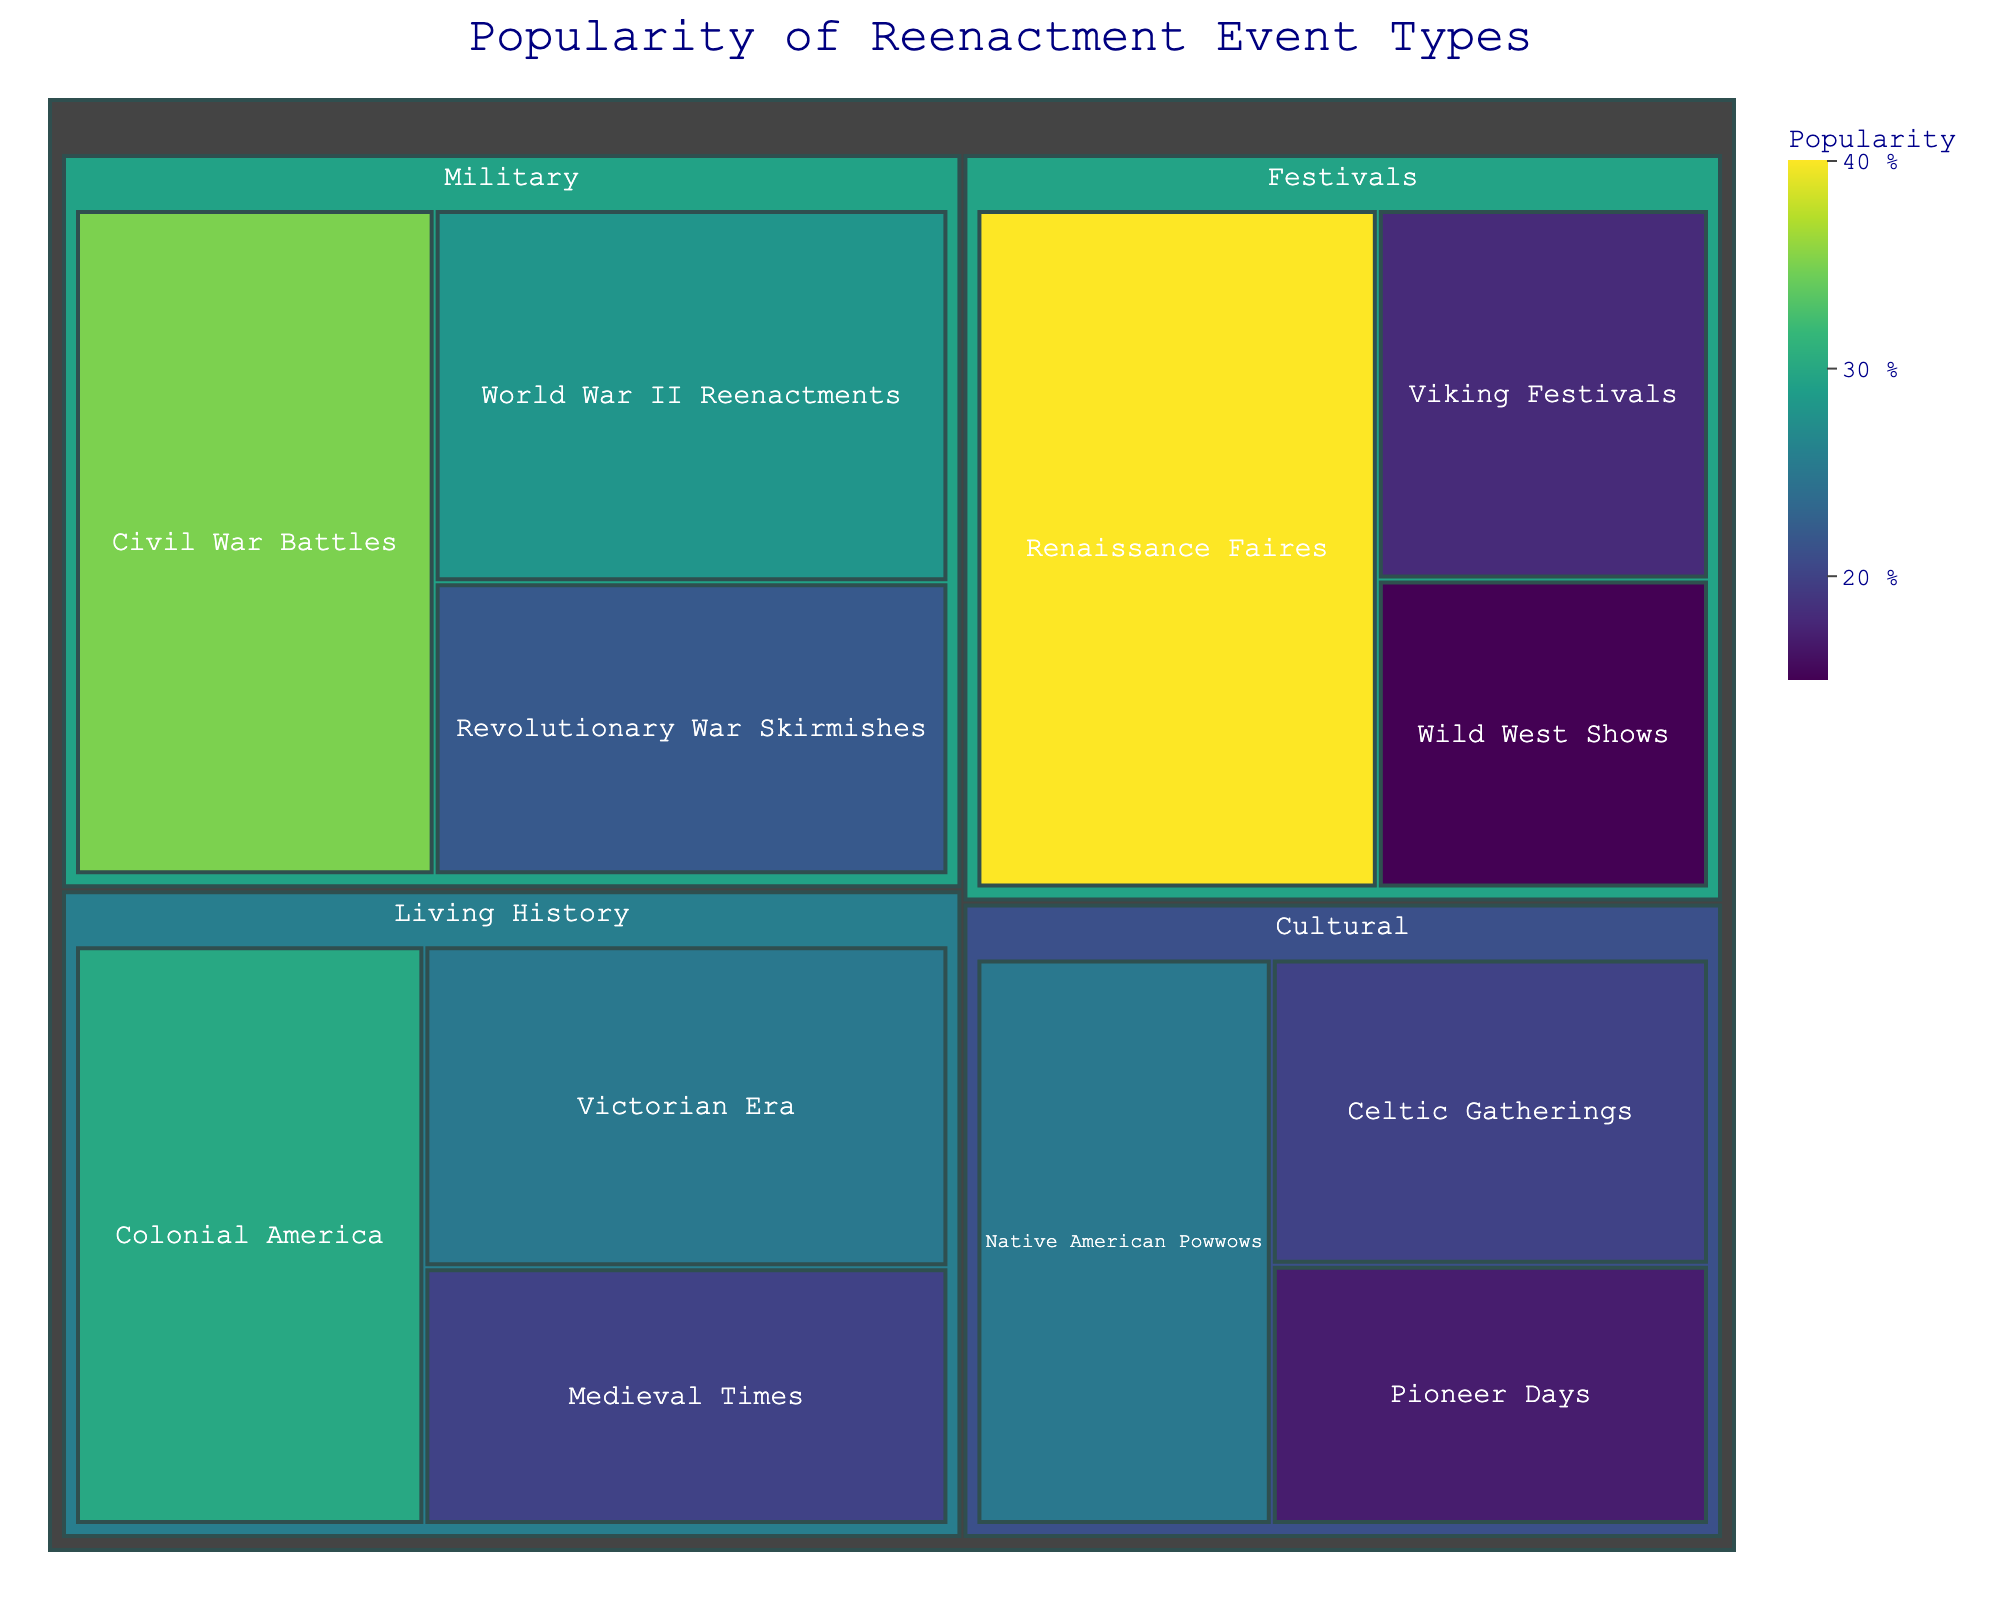Which event type has the highest popularity? Look at the values in the treemap and find the highest, which is "Renaissance Faires" under the Festivals category with a value of 40%.
Answer: Renaissance Faires Which category has the lowest total popularity? Sum up the popularity values for each category: Military (35+28+22=85), Living History (30+25+20=75), Festivals (40+18+15=73), Cultural (25+20+17=62). The Cultural category has the lowest total popularity.
Answer: Cultural What is the popularity difference between Civil War Battles and Viking Festivals? Subtract the popularity value of Viking Festivals (18%) from Civil War Battles (35%). The difference is 35% - 18% = 17%.
Answer: 17% Which event type is more popular: World War II Reenactments or Colonial America? Compare the popularity values of World War II Reenactments (28%) and Colonial America (30%). Colonial America is more popular.
Answer: Colonial America How many event types have a popularity greater than 25%? Identify and count the event types with popularity values greater than 25%: Civil War Battles (35%), Renaissance Faires (40%), Colonial America (30%), World War II Reenactments (28%). There are 4 event types with popularity greater than 25%.
Answer: 4 What is the average popularity of the event types in the Festivals category? Find the sum of the popularity values of the event types in the Festivals category (40 + 18 + 15 = 73) and divide by the number of event types (3). The average is 73 / 3 ≈ 24.33%.
Answer: 24.33% Which category has the most event types listed in the treemap? Count the number of event types under each category: Military (3), Living History (3), Festivals (3), Cultural (3). They all have the same number of event types, which is 3.
Answer: All categories have 3 event types What's the total popularity of event types in the Military category? Sum the popularity values of the event types in the Military category: 35 + 28 + 22 = 85%.
Answer: 85% Which event type in the Cultural category has the lowest popularity? Compare the popularity values of event types in the Cultural category: Native American Powwows (25%), Celtic Gatherings (20%), Pioneer Days (17%). Pioneer Days has the lowest popularity.
Answer: Pioneer Days 